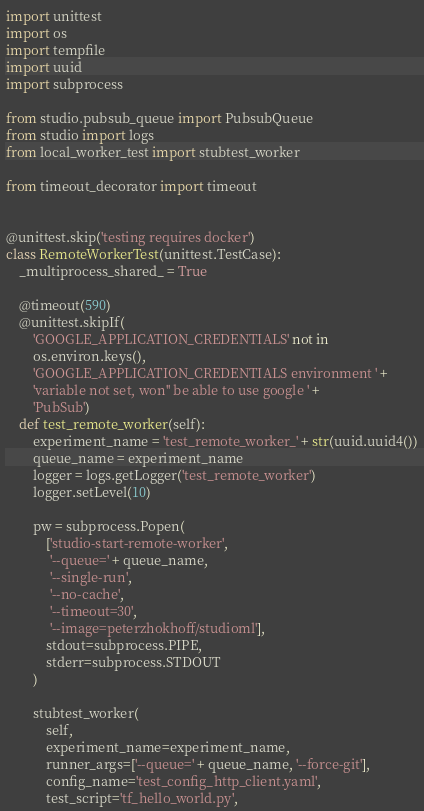<code> <loc_0><loc_0><loc_500><loc_500><_Python_>import unittest
import os
import tempfile
import uuid
import subprocess

from studio.pubsub_queue import PubsubQueue
from studio import logs
from local_worker_test import stubtest_worker

from timeout_decorator import timeout


@unittest.skip('testing requires docker')
class RemoteWorkerTest(unittest.TestCase):
    _multiprocess_shared_ = True

    @timeout(590)
    @unittest.skipIf(
        'GOOGLE_APPLICATION_CREDENTIALS' not in
        os.environ.keys(),
        'GOOGLE_APPLICATION_CREDENTIALS environment ' +
        'variable not set, won'' be able to use google ' +
        'PubSub')
    def test_remote_worker(self):
        experiment_name = 'test_remote_worker_' + str(uuid.uuid4())
        queue_name = experiment_name
        logger = logs.getLogger('test_remote_worker')
        logger.setLevel(10)

        pw = subprocess.Popen(
            ['studio-start-remote-worker',
             '--queue=' + queue_name,
             '--single-run',
             '--no-cache',
             '--timeout=30',
             '--image=peterzhokhoff/studioml'],
            stdout=subprocess.PIPE,
            stderr=subprocess.STDOUT
        )

        stubtest_worker(
            self,
            experiment_name=experiment_name,
            runner_args=['--queue=' + queue_name, '--force-git'],
            config_name='test_config_http_client.yaml',
            test_script='tf_hello_world.py',</code> 